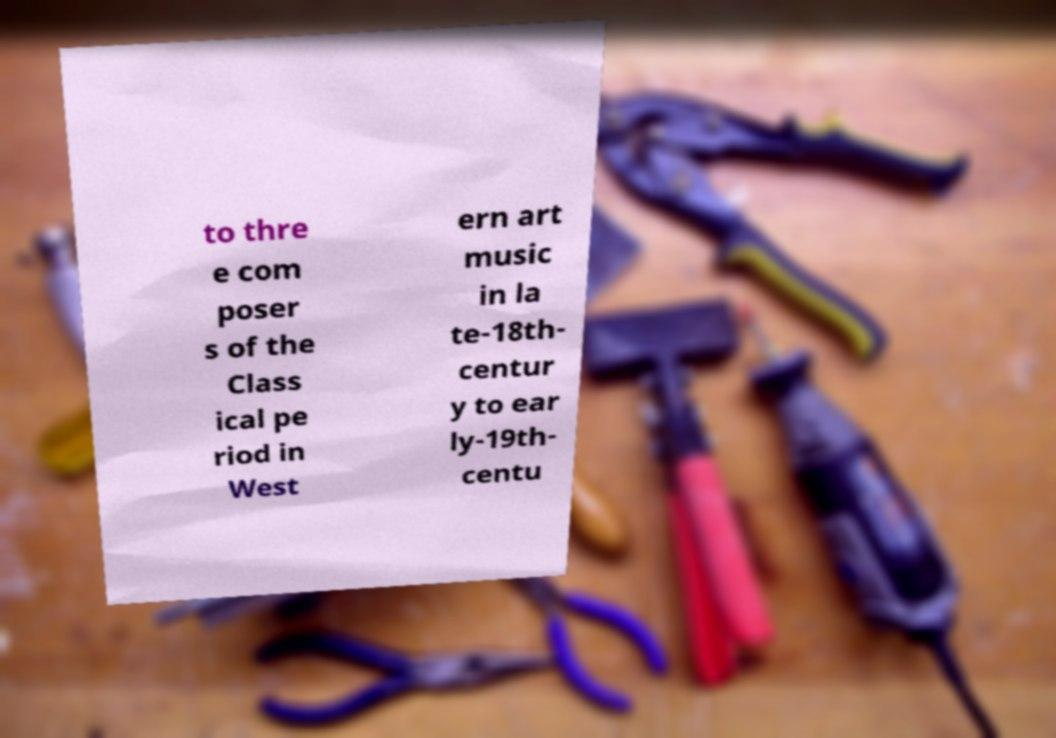Can you read and provide the text displayed in the image?This photo seems to have some interesting text. Can you extract and type it out for me? to thre e com poser s of the Class ical pe riod in West ern art music in la te-18th- centur y to ear ly-19th- centu 